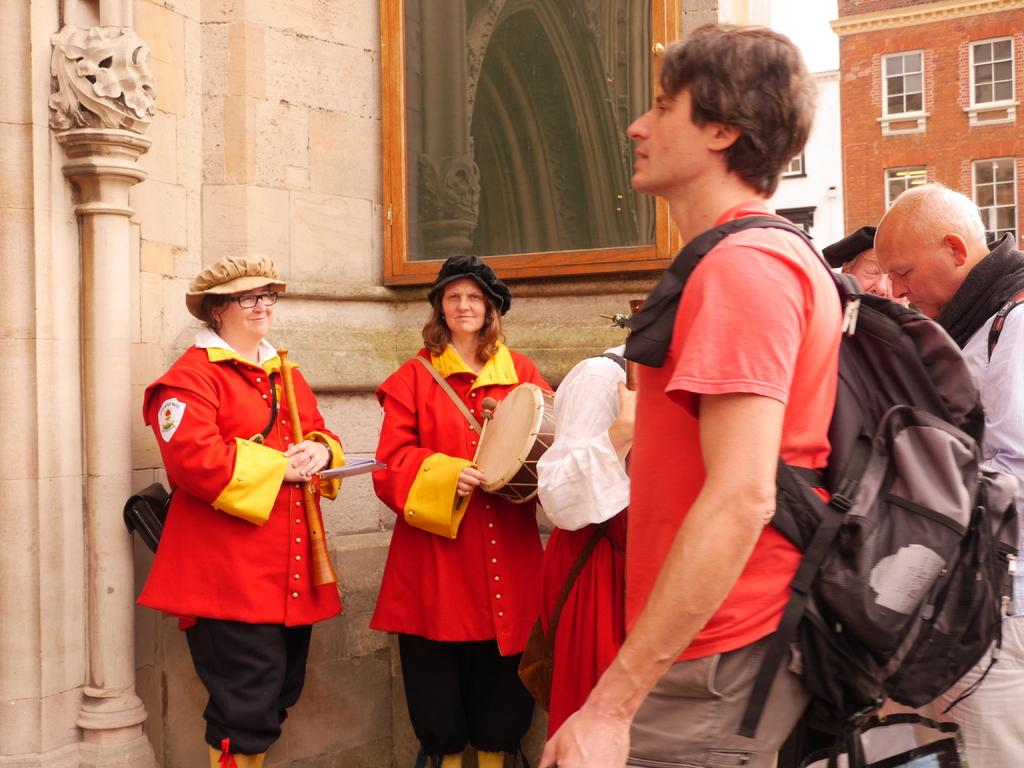How many people are in the image? There are people in the image, including a man and two women. What is the man wearing in the image? The man is wearing a bag in the image. What is the facial expression of the women in the image? The two women in the image are smiling. What can be seen in the background of the image? There are buildings in the background of the image. What is the distance between the basket and the health center in the image? There is no basket or health center present in the image. 